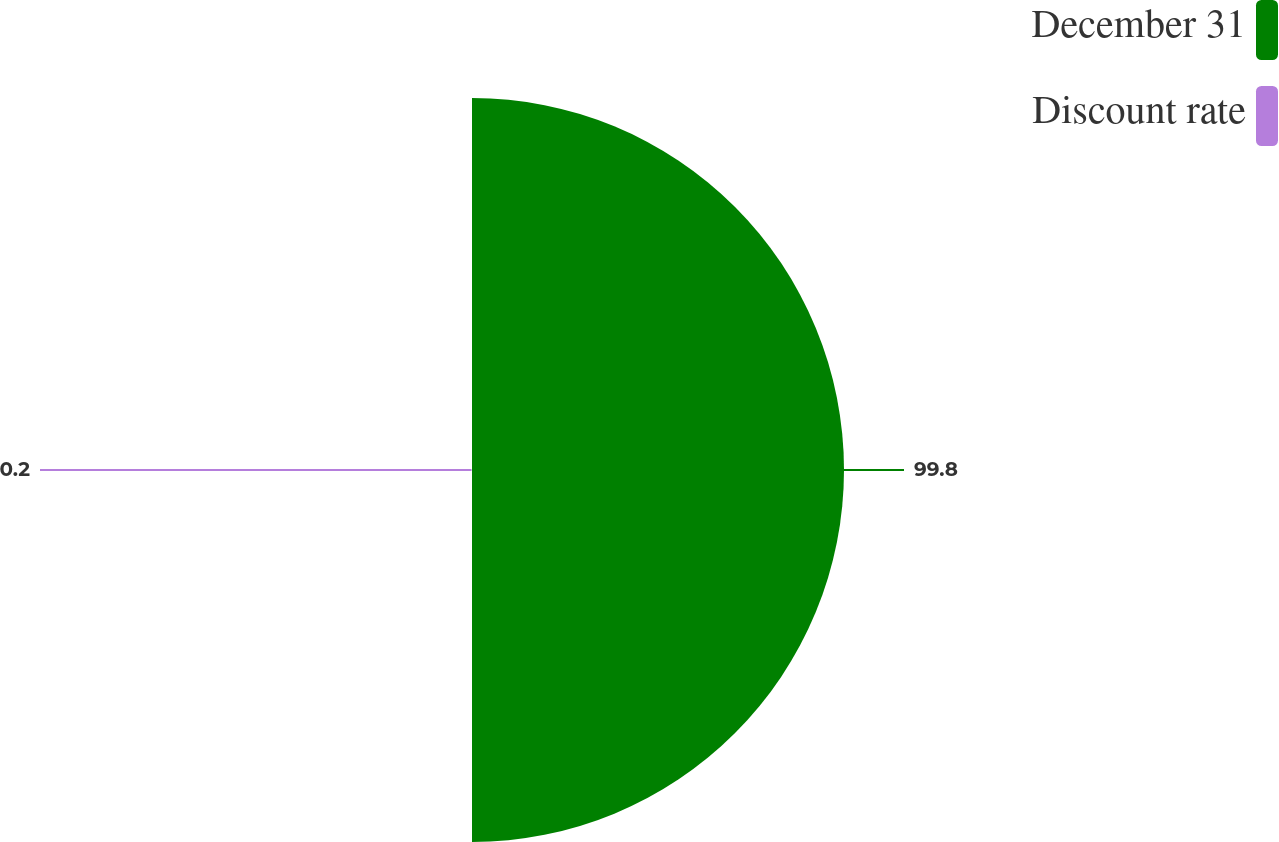Convert chart. <chart><loc_0><loc_0><loc_500><loc_500><pie_chart><fcel>December 31<fcel>Discount rate<nl><fcel>99.8%<fcel>0.2%<nl></chart> 